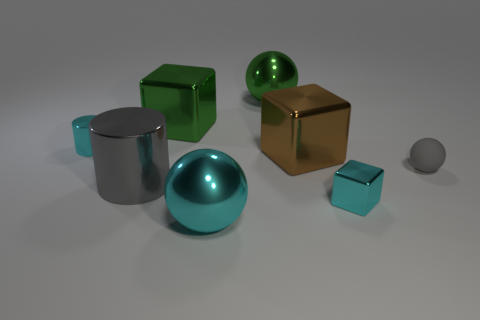Subtract all cyan cubes. How many cubes are left? 2 Add 2 metallic cylinders. How many objects exist? 10 Subtract all gray cylinders. How many cylinders are left? 1 Subtract 1 balls. How many balls are left? 2 Subtract all cubes. How many objects are left? 5 Add 2 big cylinders. How many big cylinders exist? 3 Subtract 0 red cylinders. How many objects are left? 8 Subtract all gray cubes. Subtract all gray cylinders. How many cubes are left? 3 Subtract all big green metallic balls. Subtract all cyan balls. How many objects are left? 6 Add 4 spheres. How many spheres are left? 7 